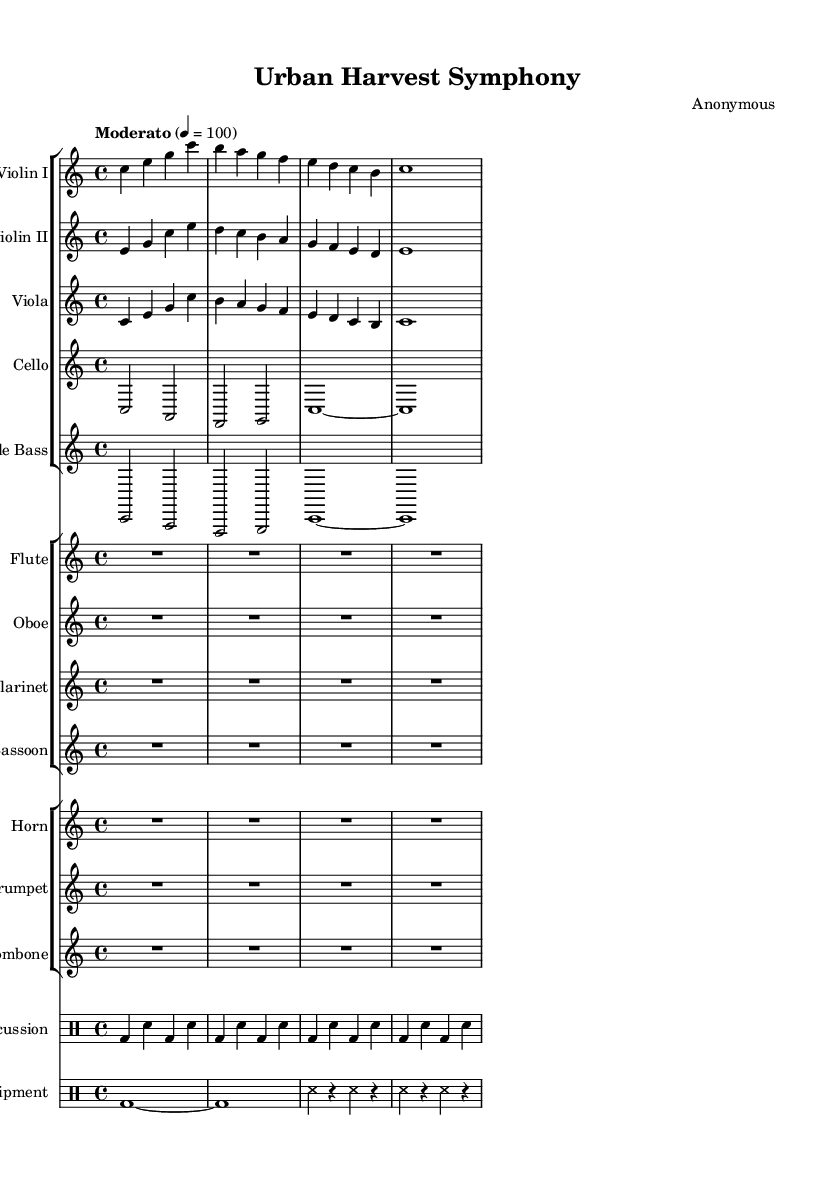What is the key signature of this music? The key signature is indicated at the beginning of the score. It shows C major, which has no sharps or flats.
Answer: C major What is the time signature of this symphony? The time signature is found directly below the key signature at the beginning of the score. It is expressed as 4/4.
Answer: 4/4 What is the tempo marking of the piece? The tempo marking is provided in the score above the staff, indicating how fast the piece should be played. In this case, it indicates "Moderato" with a metronome marking of 100 beats per minute.
Answer: Moderato, 100 How many instruments are used in the symphony? The score lists all the instruments via staff groups and shows a total of 12 individual parts. By counting the different groups, we confirm there are 12 instruments.
Answer: 12 Which instrument has a rest for the entire section? The score shows that both the flute and the oboe have a whole rest (R1*4) for the entire duration of the first measure, indicating they don't play.
Answer: Flute and Oboe What is the unique sound incorporated into the symphony? The score includes a separate percussion and drum staff specifically labeled "Farm Equipment," indicating sounds are generated from farm tools and equipment.
Answer: Farm Equipment How many measures are in the violin parts provided? Each violin part is written in four measures; we can confirm this by looking at the notation and counting each measure separately.
Answer: 4 